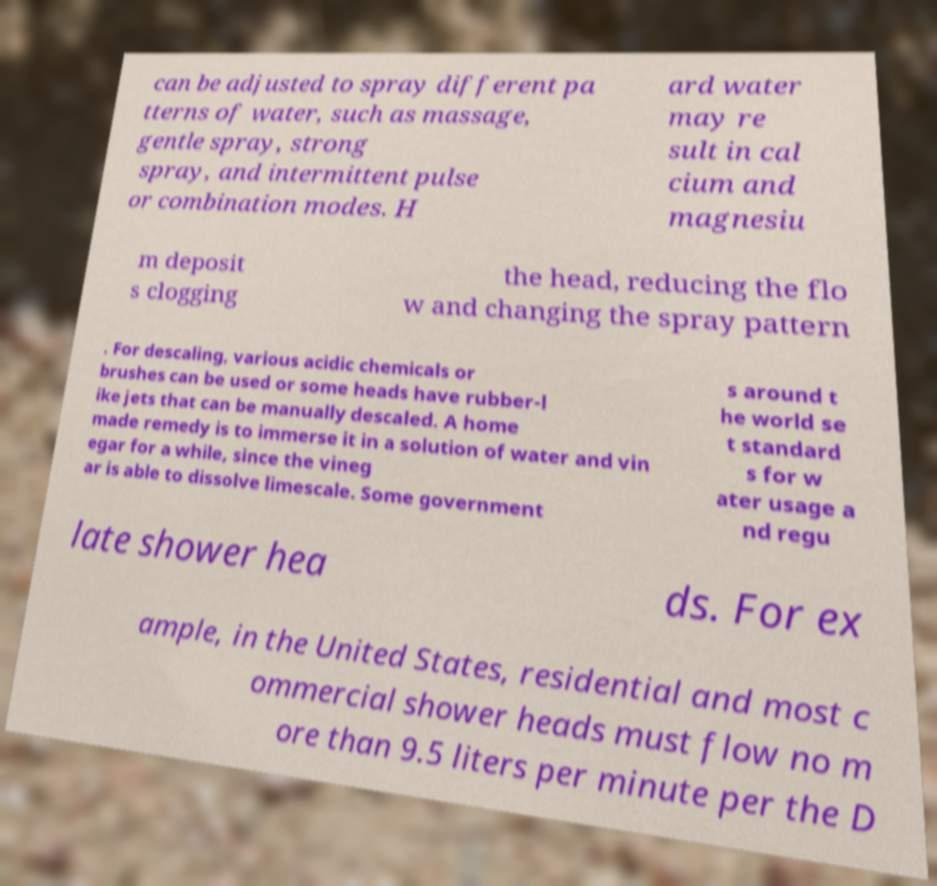Can you read and provide the text displayed in the image?This photo seems to have some interesting text. Can you extract and type it out for me? can be adjusted to spray different pa tterns of water, such as massage, gentle spray, strong spray, and intermittent pulse or combination modes. H ard water may re sult in cal cium and magnesiu m deposit s clogging the head, reducing the flo w and changing the spray pattern . For descaling, various acidic chemicals or brushes can be used or some heads have rubber-l ike jets that can be manually descaled. A home made remedy is to immerse it in a solution of water and vin egar for a while, since the vineg ar is able to dissolve limescale. Some government s around t he world se t standard s for w ater usage a nd regu late shower hea ds. For ex ample, in the United States, residential and most c ommercial shower heads must flow no m ore than 9.5 liters per minute per the D 